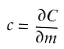<formula> <loc_0><loc_0><loc_500><loc_500>c = \frac { \partial C } { \partial m }</formula> 